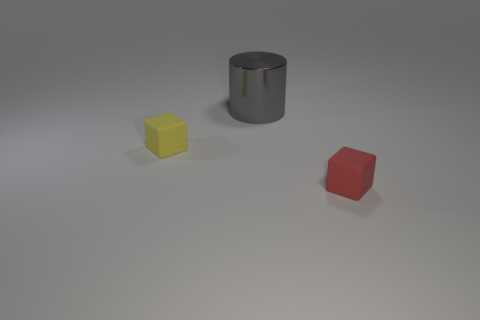Add 2 green rubber cubes. How many objects exist? 5 Subtract all cylinders. How many objects are left? 2 Add 3 large gray objects. How many large gray objects exist? 4 Subtract 0 purple balls. How many objects are left? 3 Subtract all tiny red matte objects. Subtract all green matte things. How many objects are left? 2 Add 1 rubber objects. How many rubber objects are left? 3 